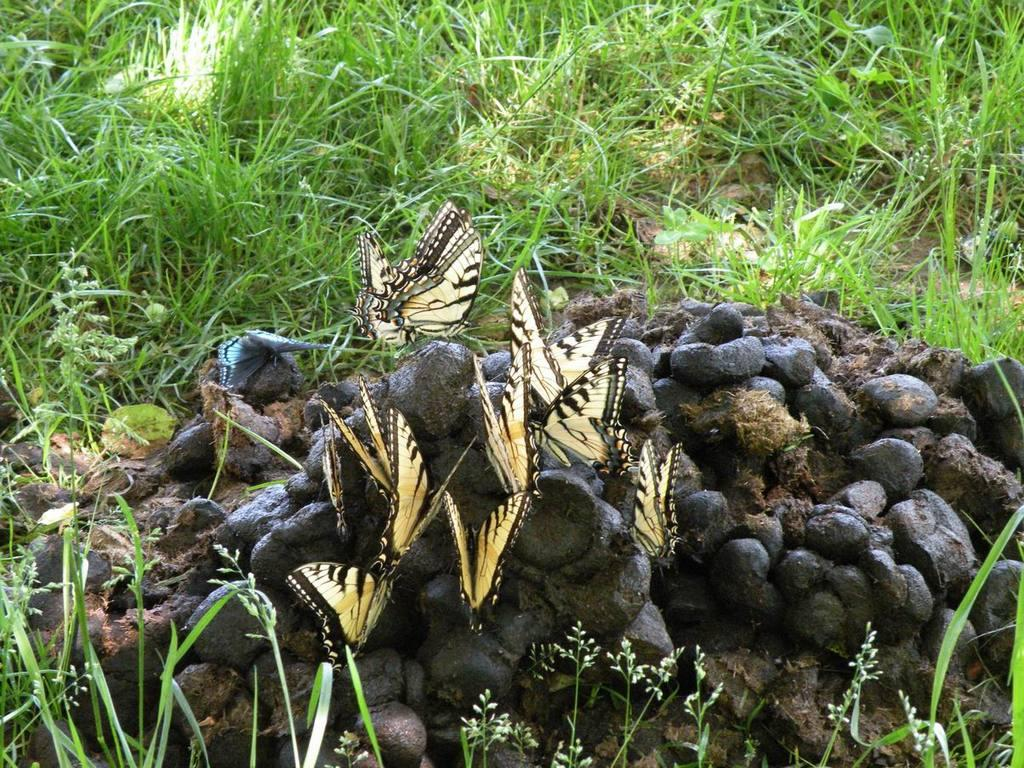What is the main subject of the image? The main subject of the image is butterflies on animal's excrement. What type of vegetation can be seen in the image? There is green grass visible at the top of the image. What type of house is visible in the image? There is no house present in the image; it features butterflies on animal's excrement and green grass. Can you tell me how many nerves are visible in the image? There are no nerves visible in the image; it features butterflies on animal's excrement and green grass. 